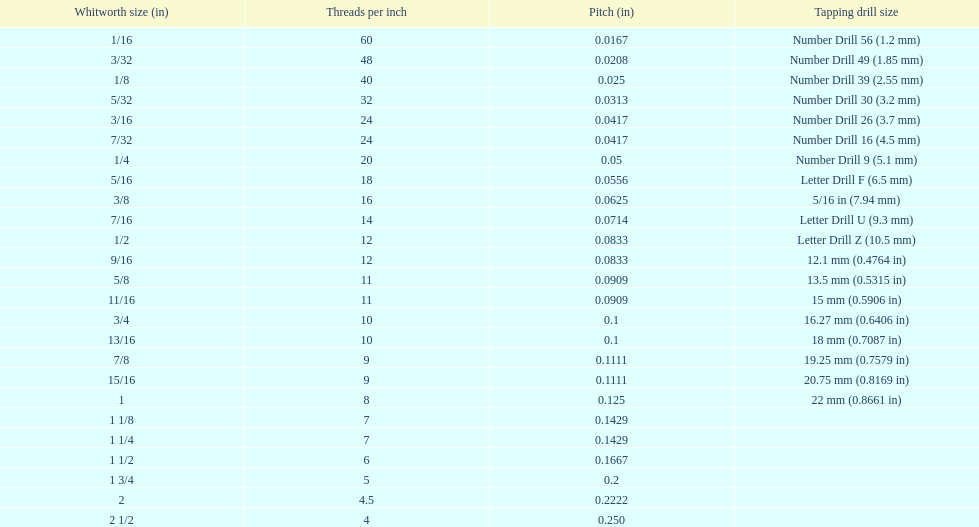What is the next whitworth size (in) below 1/8? 5/32. 